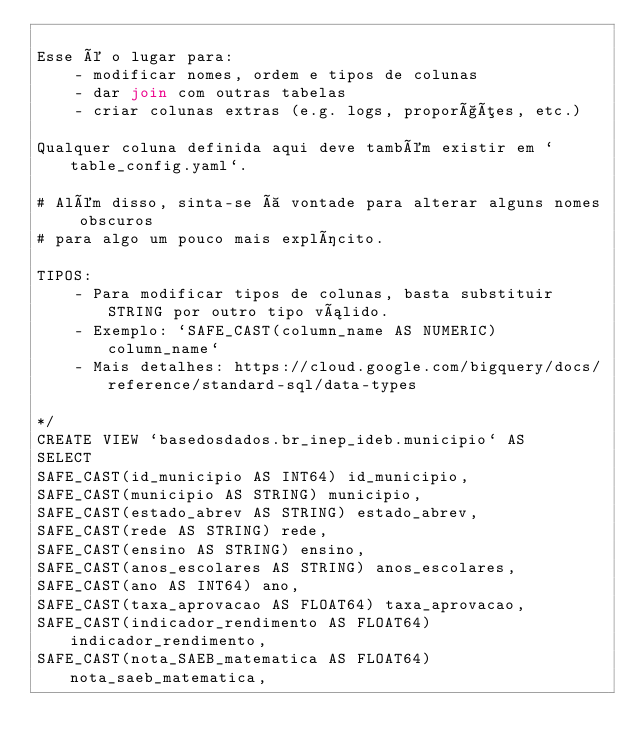<code> <loc_0><loc_0><loc_500><loc_500><_SQL_>
Esse é o lugar para:
    - modificar nomes, ordem e tipos de colunas
    - dar join com outras tabelas
    - criar colunas extras (e.g. logs, proporções, etc.)

Qualquer coluna definida aqui deve também existir em `table_config.yaml`.

# Além disso, sinta-se à vontade para alterar alguns nomes obscuros
# para algo um pouco mais explícito.

TIPOS:
    - Para modificar tipos de colunas, basta substituir STRING por outro tipo válido.
    - Exemplo: `SAFE_CAST(column_name AS NUMERIC) column_name`
    - Mais detalhes: https://cloud.google.com/bigquery/docs/reference/standard-sql/data-types

*/
CREATE VIEW `basedosdados.br_inep_ideb.municipio` AS
SELECT 
SAFE_CAST(id_municipio AS INT64) id_municipio,
SAFE_CAST(municipio AS STRING) municipio,
SAFE_CAST(estado_abrev AS STRING) estado_abrev,
SAFE_CAST(rede AS STRING) rede,
SAFE_CAST(ensino AS STRING) ensino,
SAFE_CAST(anos_escolares AS STRING) anos_escolares,
SAFE_CAST(ano AS INT64) ano,
SAFE_CAST(taxa_aprovacao AS FLOAT64) taxa_aprovacao,
SAFE_CAST(indicador_rendimento AS FLOAT64) indicador_rendimento,
SAFE_CAST(nota_SAEB_matematica AS FLOAT64) nota_saeb_matematica,</code> 